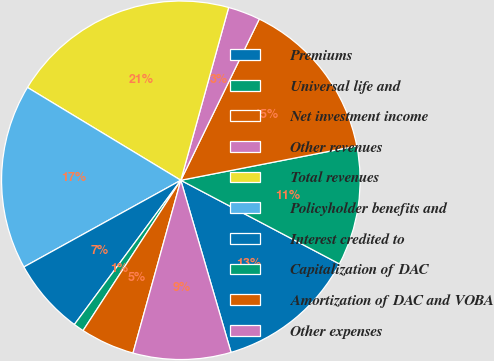Convert chart. <chart><loc_0><loc_0><loc_500><loc_500><pie_chart><fcel>Premiums<fcel>Universal life and<fcel>Net investment income<fcel>Other revenues<fcel>Total revenues<fcel>Policyholder benefits and<fcel>Interest credited to<fcel>Capitalization of DAC<fcel>Amortization of DAC and VOBA<fcel>Other expenses<nl><fcel>12.76%<fcel>10.79%<fcel>14.73%<fcel>2.91%<fcel>20.64%<fcel>16.7%<fcel>6.85%<fcel>0.94%<fcel>4.88%<fcel>8.82%<nl></chart> 